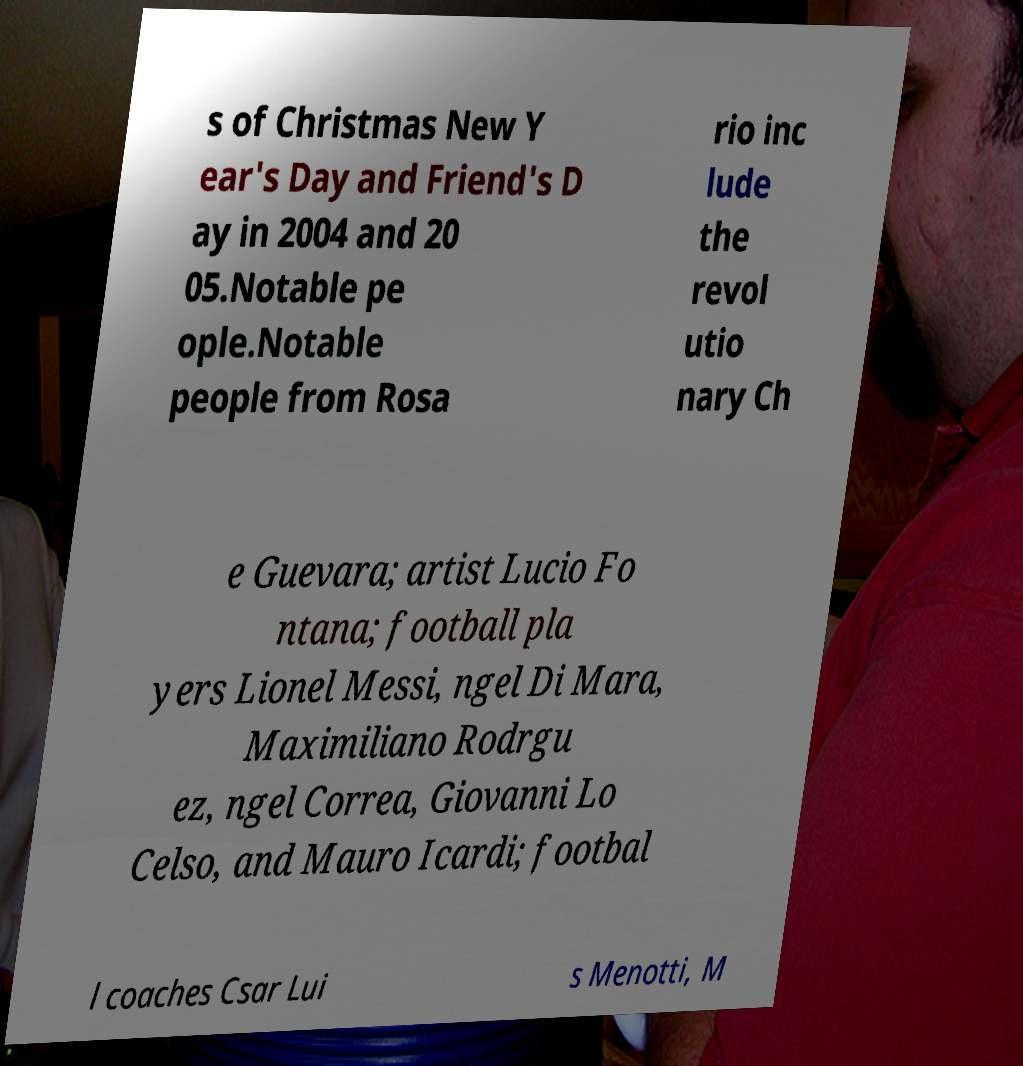I need the written content from this picture converted into text. Can you do that? s of Christmas New Y ear's Day and Friend's D ay in 2004 and 20 05.Notable pe ople.Notable people from Rosa rio inc lude the revol utio nary Ch e Guevara; artist Lucio Fo ntana; football pla yers Lionel Messi, ngel Di Mara, Maximiliano Rodrgu ez, ngel Correa, Giovanni Lo Celso, and Mauro Icardi; footbal l coaches Csar Lui s Menotti, M 